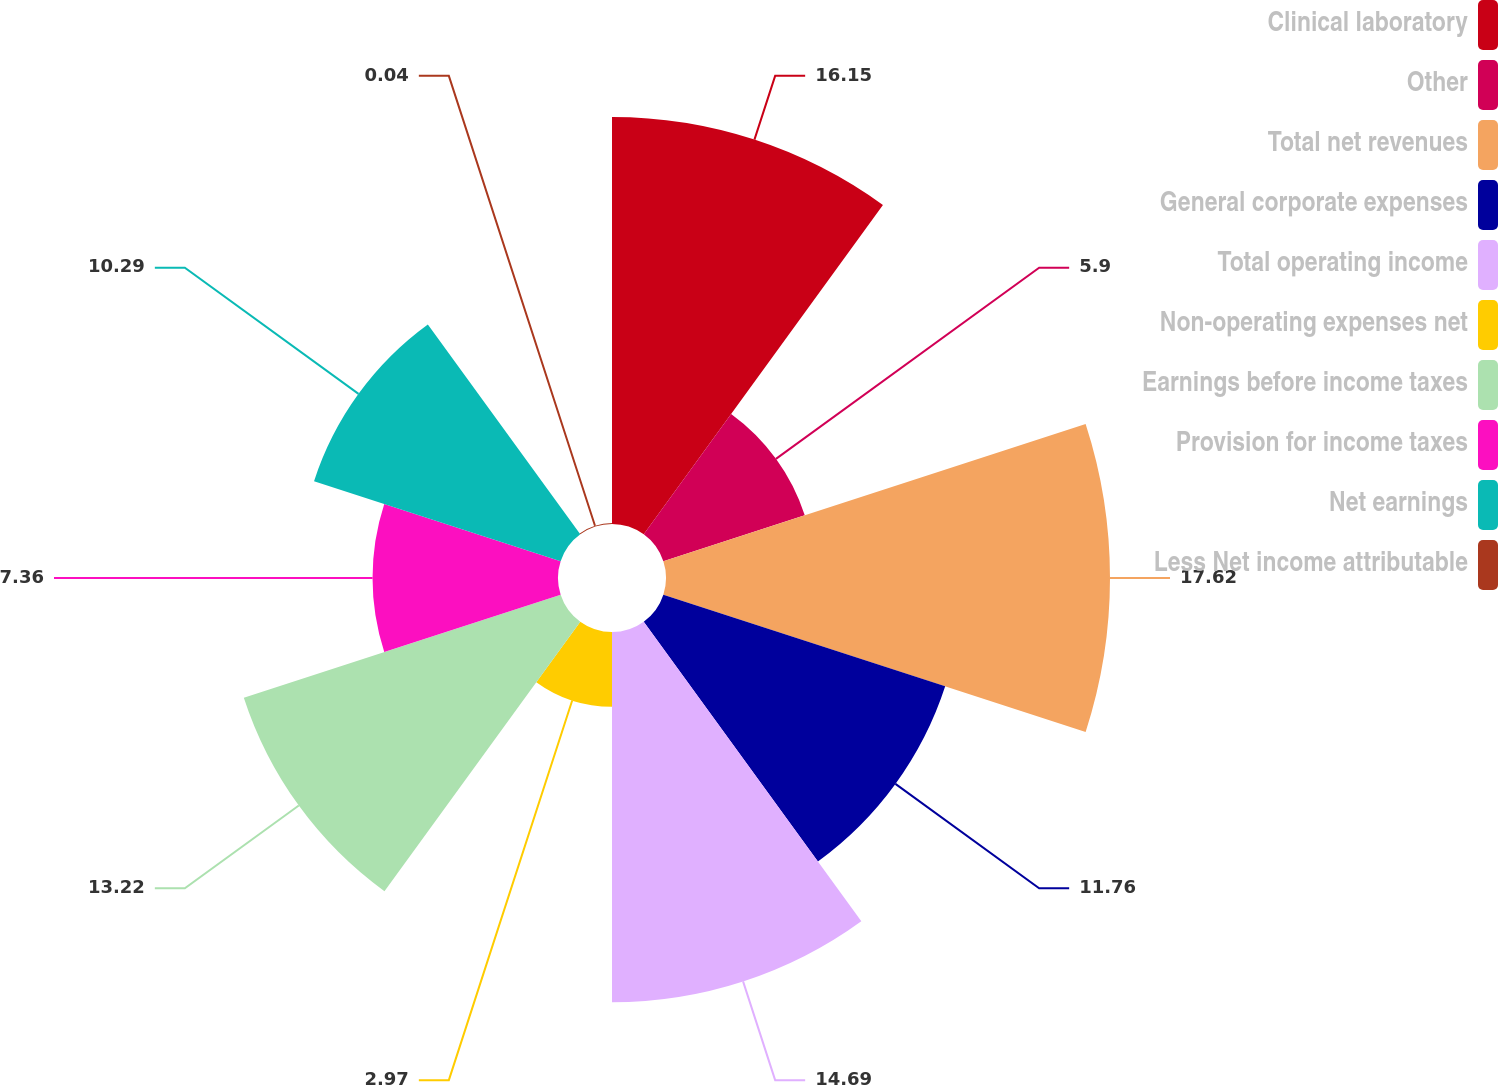Convert chart to OTSL. <chart><loc_0><loc_0><loc_500><loc_500><pie_chart><fcel>Clinical laboratory<fcel>Other<fcel>Total net revenues<fcel>General corporate expenses<fcel>Total operating income<fcel>Non-operating expenses net<fcel>Earnings before income taxes<fcel>Provision for income taxes<fcel>Net earnings<fcel>Less Net income attributable<nl><fcel>16.15%<fcel>5.9%<fcel>17.62%<fcel>11.76%<fcel>14.69%<fcel>2.97%<fcel>13.22%<fcel>7.36%<fcel>10.29%<fcel>0.04%<nl></chart> 